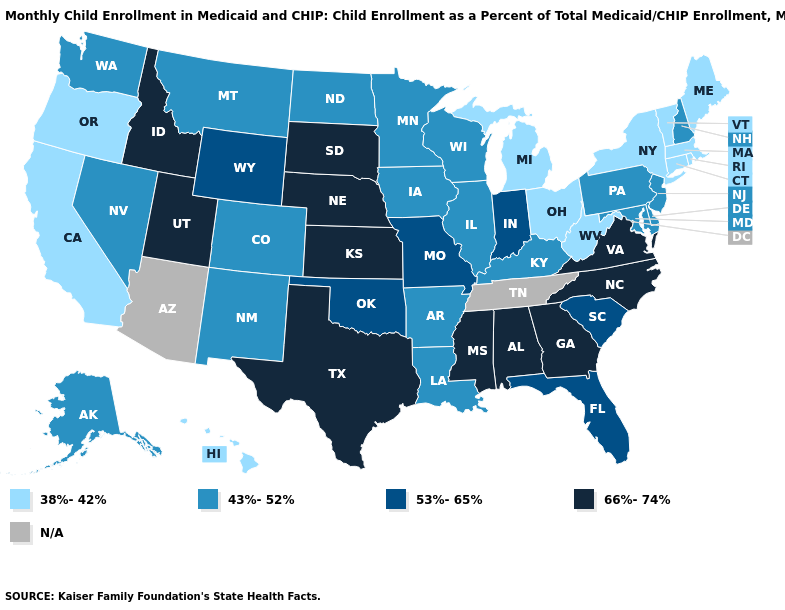Does Massachusetts have the lowest value in the USA?
Give a very brief answer. Yes. Name the states that have a value in the range 66%-74%?
Quick response, please. Alabama, Georgia, Idaho, Kansas, Mississippi, Nebraska, North Carolina, South Dakota, Texas, Utah, Virginia. What is the value of Wisconsin?
Answer briefly. 43%-52%. What is the value of Vermont?
Keep it brief. 38%-42%. What is the highest value in states that border Oregon?
Quick response, please. 66%-74%. What is the value of South Carolina?
Quick response, please. 53%-65%. Among the states that border Vermont , does New Hampshire have the lowest value?
Keep it brief. No. What is the value of Connecticut?
Write a very short answer. 38%-42%. What is the value of Massachusetts?
Answer briefly. 38%-42%. What is the highest value in the USA?
Answer briefly. 66%-74%. What is the value of Maryland?
Quick response, please. 43%-52%. 